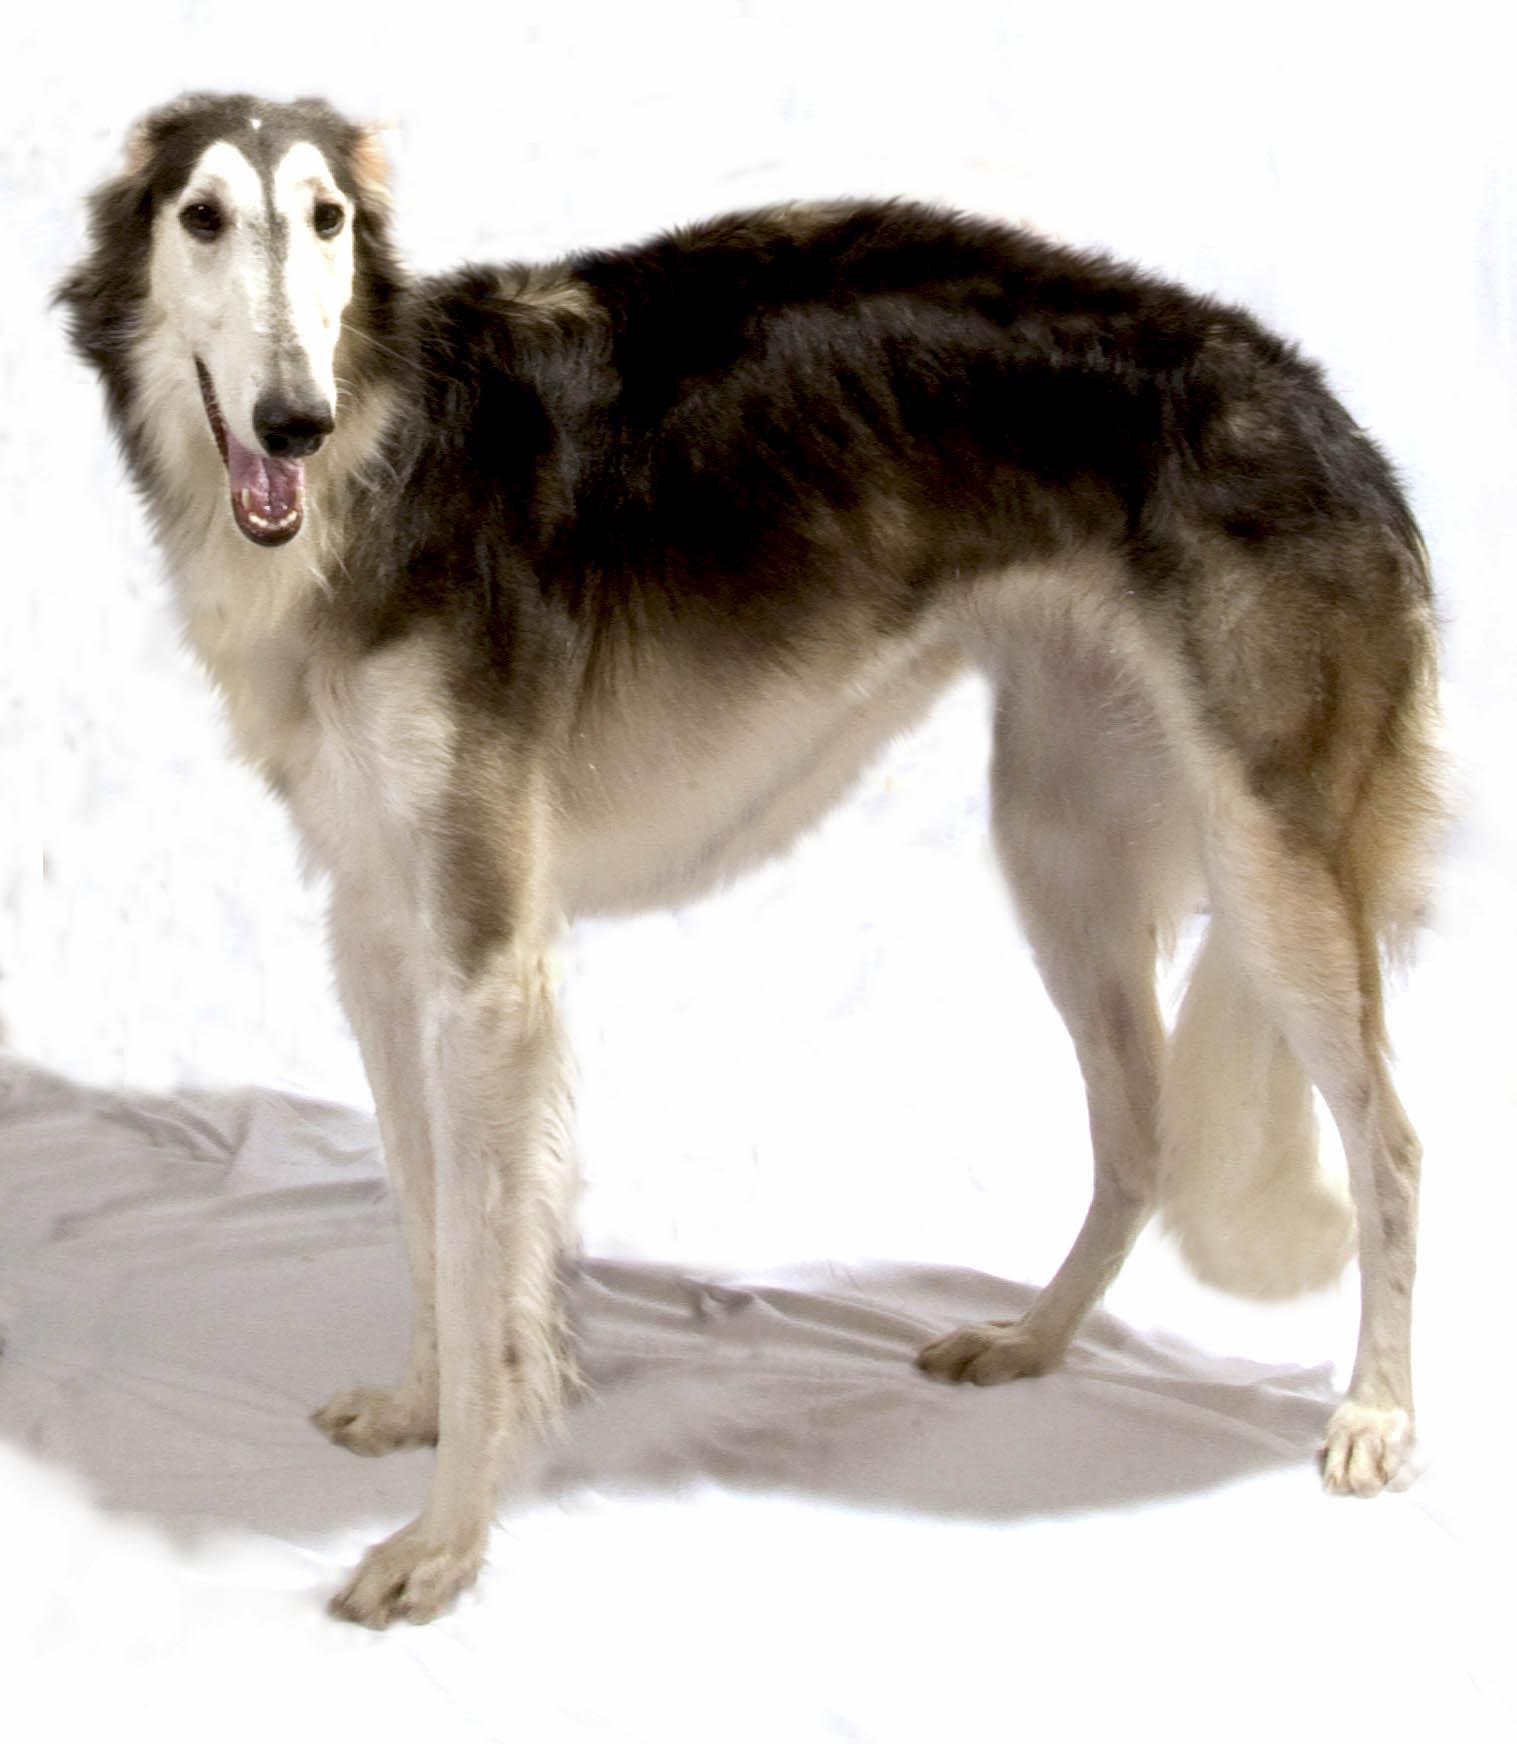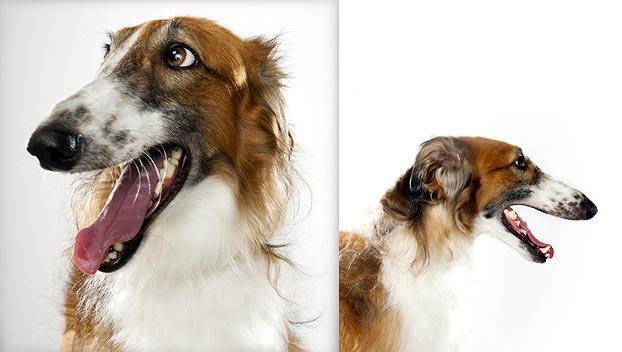The first image is the image on the left, the second image is the image on the right. Evaluate the accuracy of this statement regarding the images: "An image shows a hound standing on the grassy ground.". Is it true? Answer yes or no. No. 